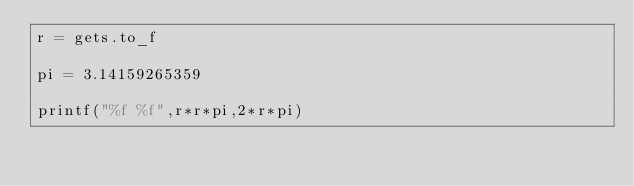<code> <loc_0><loc_0><loc_500><loc_500><_Ruby_>r = gets.to_f

pi = 3.14159265359

printf("%f %f",r*r*pi,2*r*pi)
</code> 